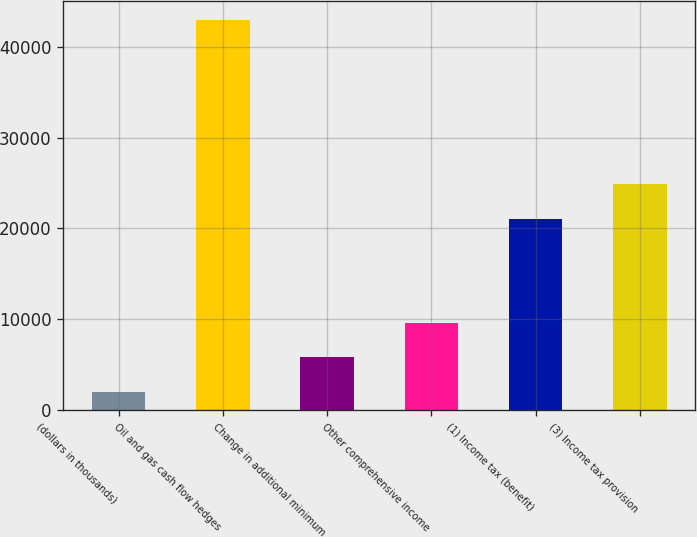Convert chart to OTSL. <chart><loc_0><loc_0><loc_500><loc_500><bar_chart><fcel>(dollars in thousands)<fcel>Oil and gas cash flow hedges<fcel>Change in additional minimum<fcel>Other comprehensive income<fcel>(1) Income tax (benefit)<fcel>(3) Income tax provision<nl><fcel>2004<fcel>42944.6<fcel>5787.6<fcel>9571.2<fcel>21087<fcel>24870.6<nl></chart> 